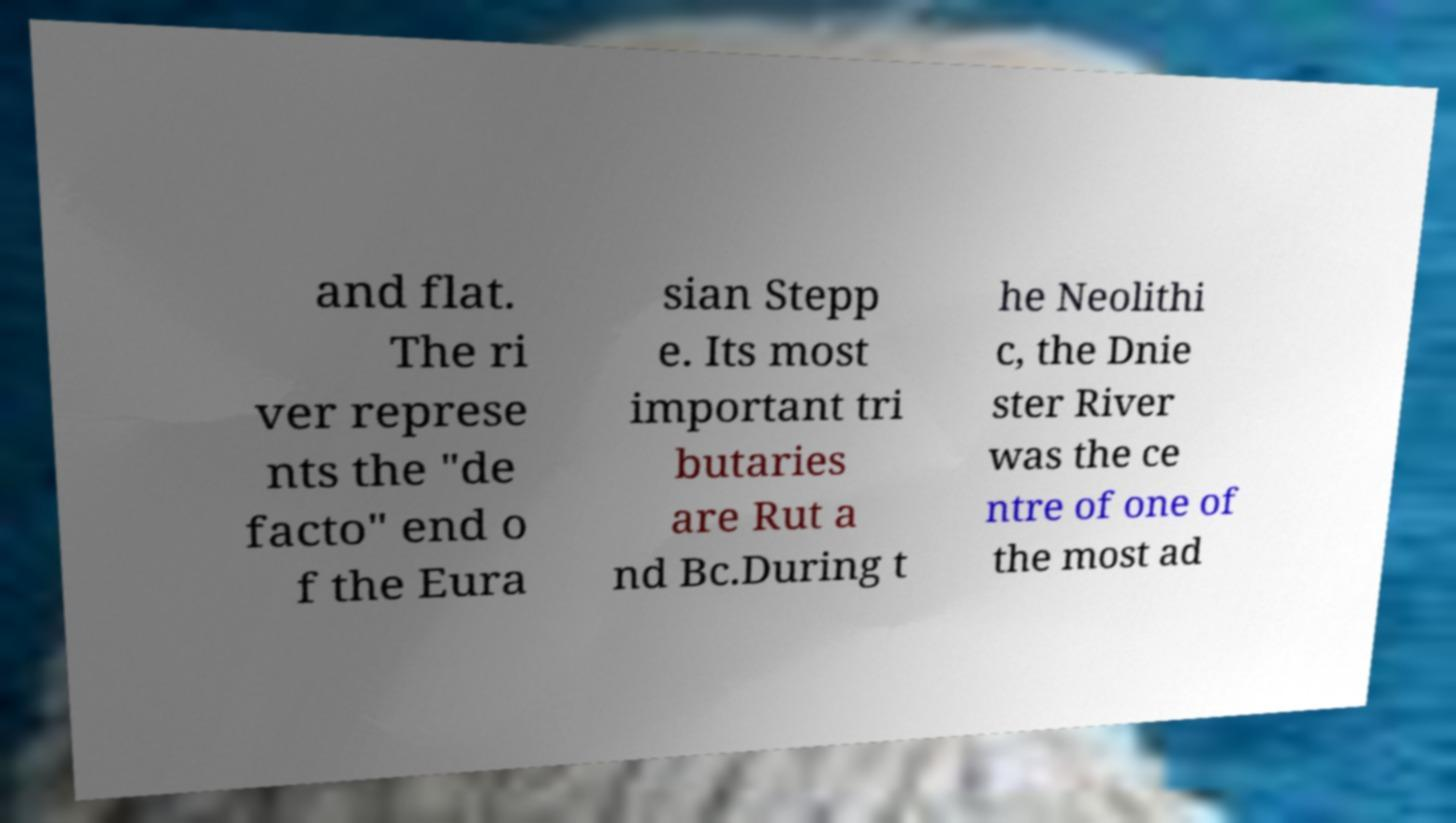I need the written content from this picture converted into text. Can you do that? and flat. The ri ver represe nts the "de facto" end o f the Eura sian Stepp e. Its most important tri butaries are Rut a nd Bc.During t he Neolithi c, the Dnie ster River was the ce ntre of one of the most ad 